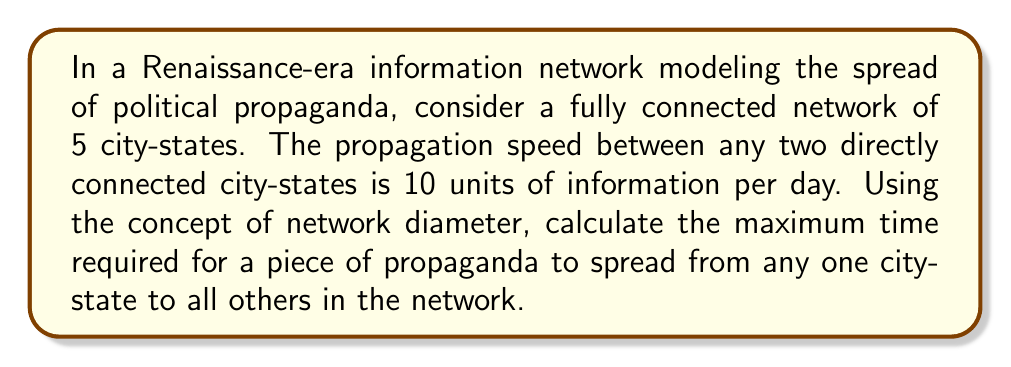Can you solve this math problem? To solve this problem, we need to understand and apply the following concepts:

1. Fully connected network: Every node (city-state) is directly connected to every other node.
2. Network diameter: The longest shortest path between any two nodes in the network.
3. Propagation speed: The rate at which information travels between directly connected nodes.

Let's approach this step-by-step:

1. In a fully connected network of 5 nodes, each node is directly connected to the other 4 nodes.

2. The network diameter in a fully connected network is always 1, as any node can reach any other node in a single step.

3. Given:
   - Number of nodes (city-states) $n = 5$
   - Propagation speed $s = 10$ units of information per day
   - Network diameter $d = 1$

4. The maximum time $t$ for information to spread from one node to all others is:

   $$t = \frac{d}{s} = \frac{1}{10} = 0.1\text{ days}$$

5. To convert this to a more practical unit, let's express it in hours:

   $$t_{\text{hours}} = 0.1 \times 24 = 2.4\text{ hours}$$

Therefore, it takes a maximum of 2.4 hours for a piece of propaganda to spread from any one city-state to all others in this Renaissance-era network.
Answer: 2.4 hours 